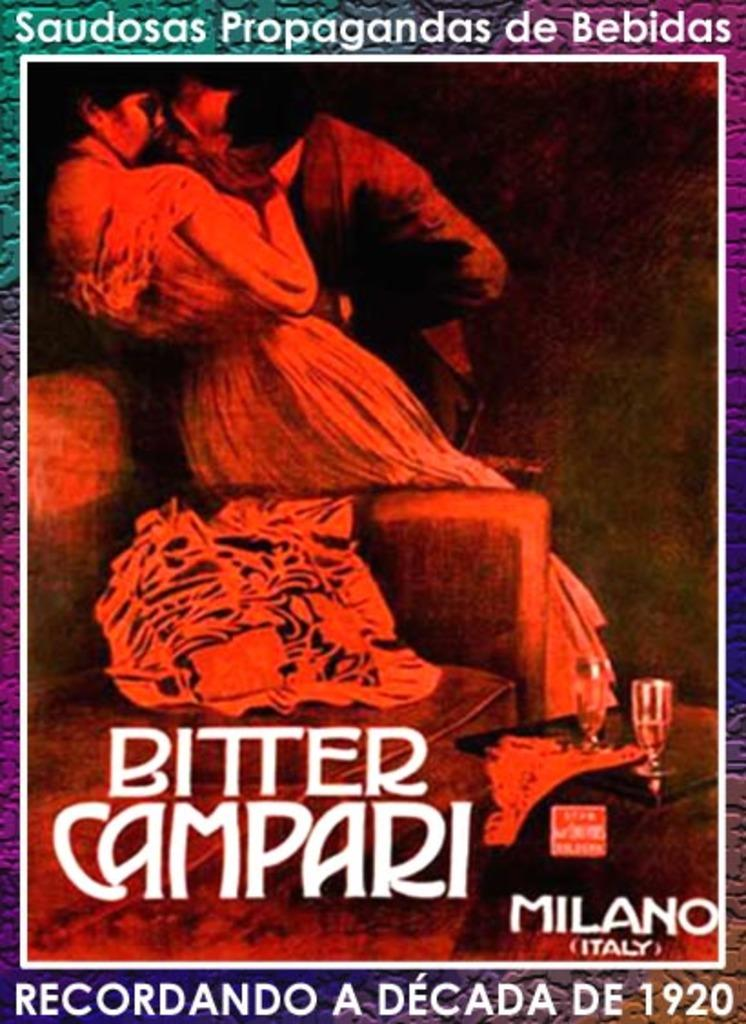<image>
Share a concise interpretation of the image provided. A book with a man and woman kissing on the cover called Bitter Campari. 